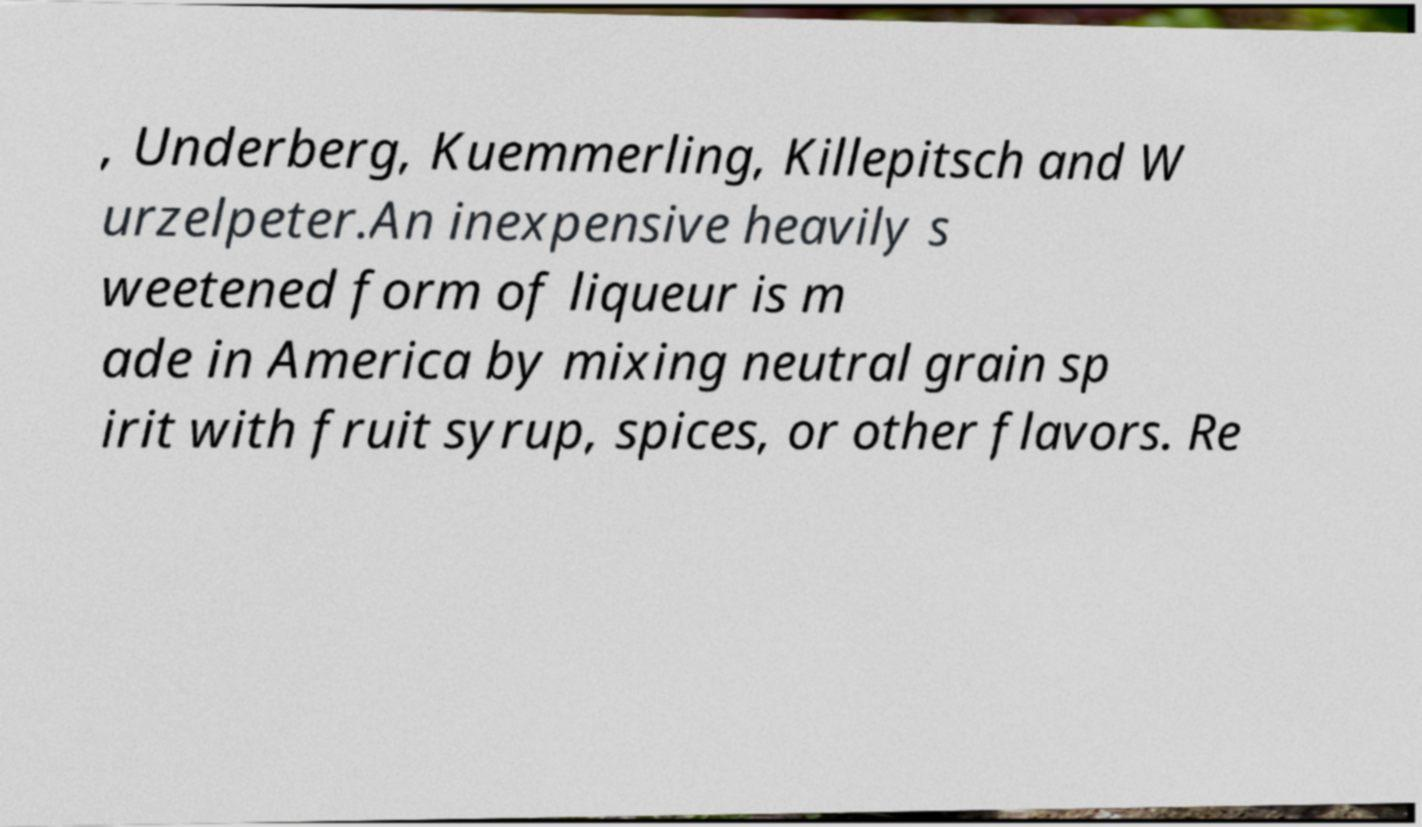Could you extract and type out the text from this image? , Underberg, Kuemmerling, Killepitsch and W urzelpeter.An inexpensive heavily s weetened form of liqueur is m ade in America by mixing neutral grain sp irit with fruit syrup, spices, or other flavors. Re 